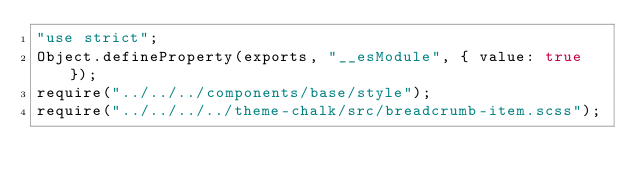Convert code to text. <code><loc_0><loc_0><loc_500><loc_500><_JavaScript_>"use strict";
Object.defineProperty(exports, "__esModule", { value: true });
require("../../../components/base/style");
require("../../../../theme-chalk/src/breadcrumb-item.scss");
</code> 